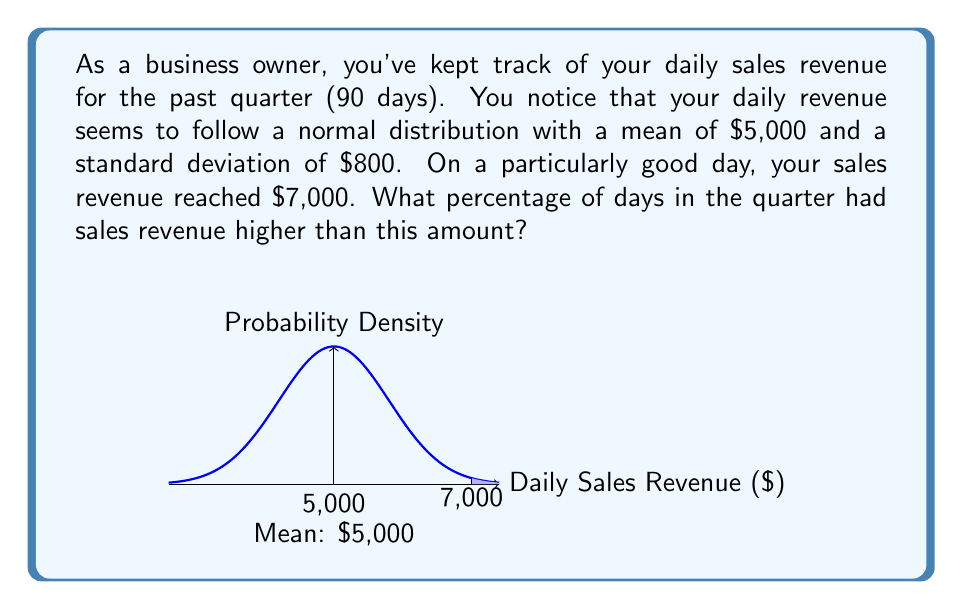Could you help me with this problem? Let's approach this step-by-step:

1) We're dealing with a normal distribution where:
   $\mu = 5000$ (mean)
   $\sigma = 800$ (standard deviation)

2) We want to find the probability of having sales revenue higher than $7,000.

3) To do this, we need to calculate the z-score for $7,000:

   $$z = \frac{x - \mu}{\sigma} = \frac{7000 - 5000}{800} = \frac{2000}{800} = 2.5$$

4) This z-score of 2.5 represents the number of standard deviations $7,000 is above the mean.

5) Now, we need to find the area under the normal curve to the right of z = 2.5. This represents the probability of having a value greater than 2.5 standard deviations above the mean.

6) Using a standard normal distribution table or calculator, we can find that:
   $P(Z > 2.5) \approx 0.0062$

7) This means that approximately 0.62% of the days had sales revenue higher than $7,000.

8) To convert this to a percentage of days in the quarter:
   $0.0062 \times 90 \text{ days} \approx 0.558 \text{ days}$

This means that, on average, sales revenue exceeded $7,000 on about 0.56 days out of the 90-day quarter.
Answer: 0.62% of days 